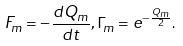<formula> <loc_0><loc_0><loc_500><loc_500>F _ { m } = - \frac { d Q _ { m } } { d t } , \Gamma _ { m } = e ^ { - \frac { Q _ { m } } { 2 } } .</formula> 